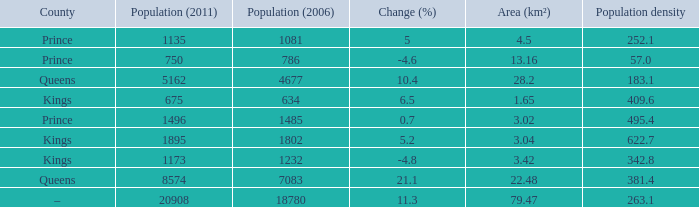What is the Population density that has a Change (%) higher than 10.4, and a Population (2011) less than 8574, in the County of Queens? None. 